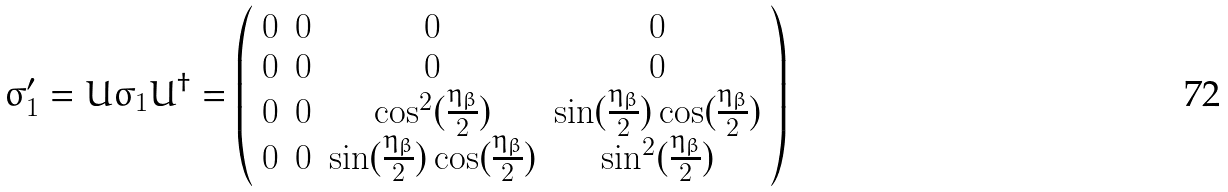Convert formula to latex. <formula><loc_0><loc_0><loc_500><loc_500>\sigma _ { 1 } ^ { \prime } = U \sigma _ { 1 } U ^ { \dagger } = \left ( \begin{array} { c c c c } 0 & 0 & 0 & 0 \\ 0 & 0 & 0 & 0 \\ 0 & 0 & \cos ^ { 2 } ( \frac { \eta _ { \beta } } { 2 } ) & \sin ( \frac { \eta _ { \beta } } { 2 } ) \cos ( \frac { \eta _ { \beta } } { 2 } ) \\ 0 & 0 & \sin ( \frac { \eta _ { \beta } } { 2 } ) \cos ( \frac { \eta _ { \beta } } { 2 } ) & \sin ^ { 2 } ( \frac { \eta _ { \beta } } { 2 } ) \end{array} \right )</formula> 